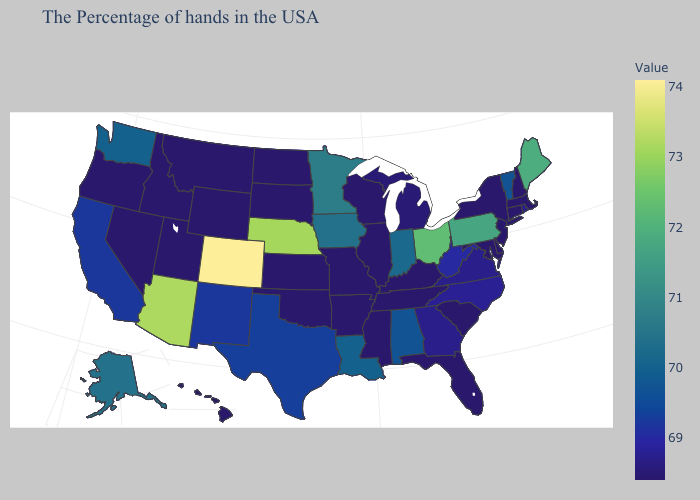Among the states that border Tennessee , which have the highest value?
Keep it brief. Alabama. Which states have the lowest value in the USA?
Quick response, please. Massachusetts, New Hampshire, Connecticut, New York, New Jersey, Delaware, Maryland, South Carolina, Florida, Kentucky, Tennessee, Wisconsin, Illinois, Mississippi, Missouri, Arkansas, Kansas, Oklahoma, South Dakota, North Dakota, Wyoming, Utah, Montana, Idaho, Nevada, Oregon, Hawaii. Does Colorado have the highest value in the USA?
Concise answer only. Yes. Among the states that border Tennessee , which have the highest value?
Quick response, please. Alabama. Which states hav the highest value in the South?
Be succinct. Louisiana. 